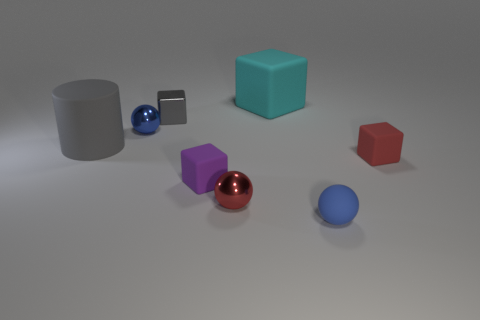Subtract 1 cubes. How many cubes are left? 3 Add 1 purple matte cubes. How many objects exist? 9 Subtract all cylinders. How many objects are left? 7 Subtract all yellow rubber balls. Subtract all tiny blocks. How many objects are left? 5 Add 4 small metallic things. How many small metallic things are left? 7 Add 6 cyan rubber objects. How many cyan rubber objects exist? 7 Subtract 0 green spheres. How many objects are left? 8 